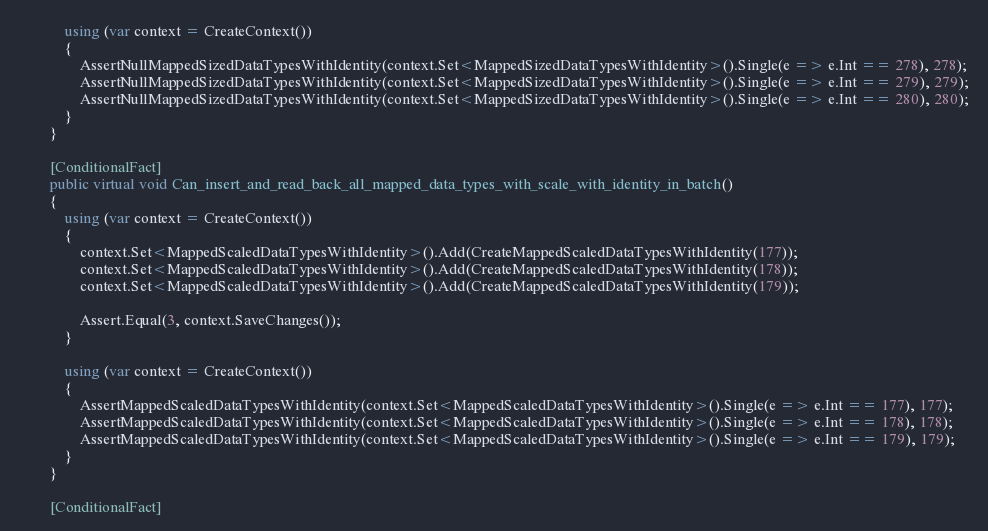Convert code to text. <code><loc_0><loc_0><loc_500><loc_500><_C#_>            using (var context = CreateContext())
            {
                AssertNullMappedSizedDataTypesWithIdentity(context.Set<MappedSizedDataTypesWithIdentity>().Single(e => e.Int == 278), 278);
                AssertNullMappedSizedDataTypesWithIdentity(context.Set<MappedSizedDataTypesWithIdentity>().Single(e => e.Int == 279), 279);
                AssertNullMappedSizedDataTypesWithIdentity(context.Set<MappedSizedDataTypesWithIdentity>().Single(e => e.Int == 280), 280);
            }
        }

        [ConditionalFact]
        public virtual void Can_insert_and_read_back_all_mapped_data_types_with_scale_with_identity_in_batch()
        {
            using (var context = CreateContext())
            {
                context.Set<MappedScaledDataTypesWithIdentity>().Add(CreateMappedScaledDataTypesWithIdentity(177));
                context.Set<MappedScaledDataTypesWithIdentity>().Add(CreateMappedScaledDataTypesWithIdentity(178));
                context.Set<MappedScaledDataTypesWithIdentity>().Add(CreateMappedScaledDataTypesWithIdentity(179));

                Assert.Equal(3, context.SaveChanges());
            }

            using (var context = CreateContext())
            {
                AssertMappedScaledDataTypesWithIdentity(context.Set<MappedScaledDataTypesWithIdentity>().Single(e => e.Int == 177), 177);
                AssertMappedScaledDataTypesWithIdentity(context.Set<MappedScaledDataTypesWithIdentity>().Single(e => e.Int == 178), 178);
                AssertMappedScaledDataTypesWithIdentity(context.Set<MappedScaledDataTypesWithIdentity>().Single(e => e.Int == 179), 179);
            }
        }

        [ConditionalFact]</code> 